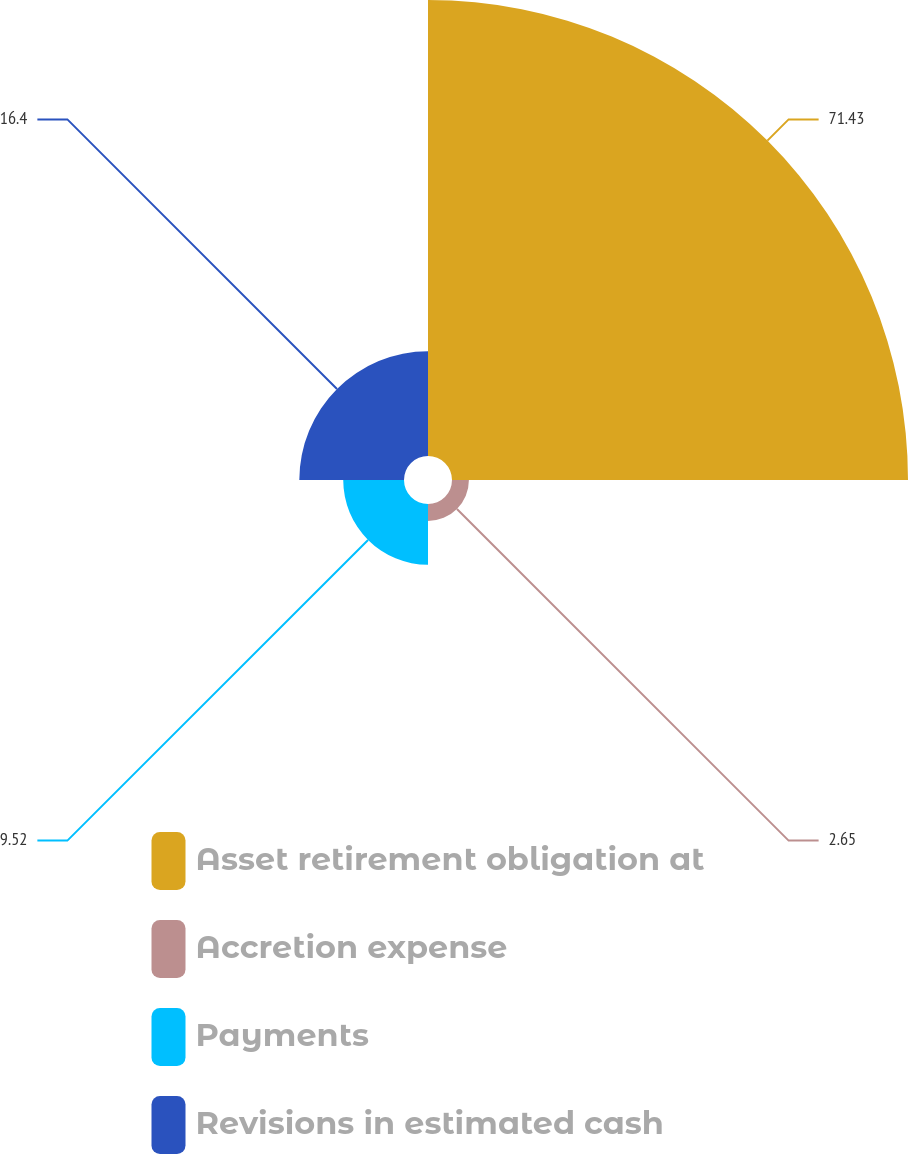<chart> <loc_0><loc_0><loc_500><loc_500><pie_chart><fcel>Asset retirement obligation at<fcel>Accretion expense<fcel>Payments<fcel>Revisions in estimated cash<nl><fcel>71.43%<fcel>2.65%<fcel>9.52%<fcel>16.4%<nl></chart> 